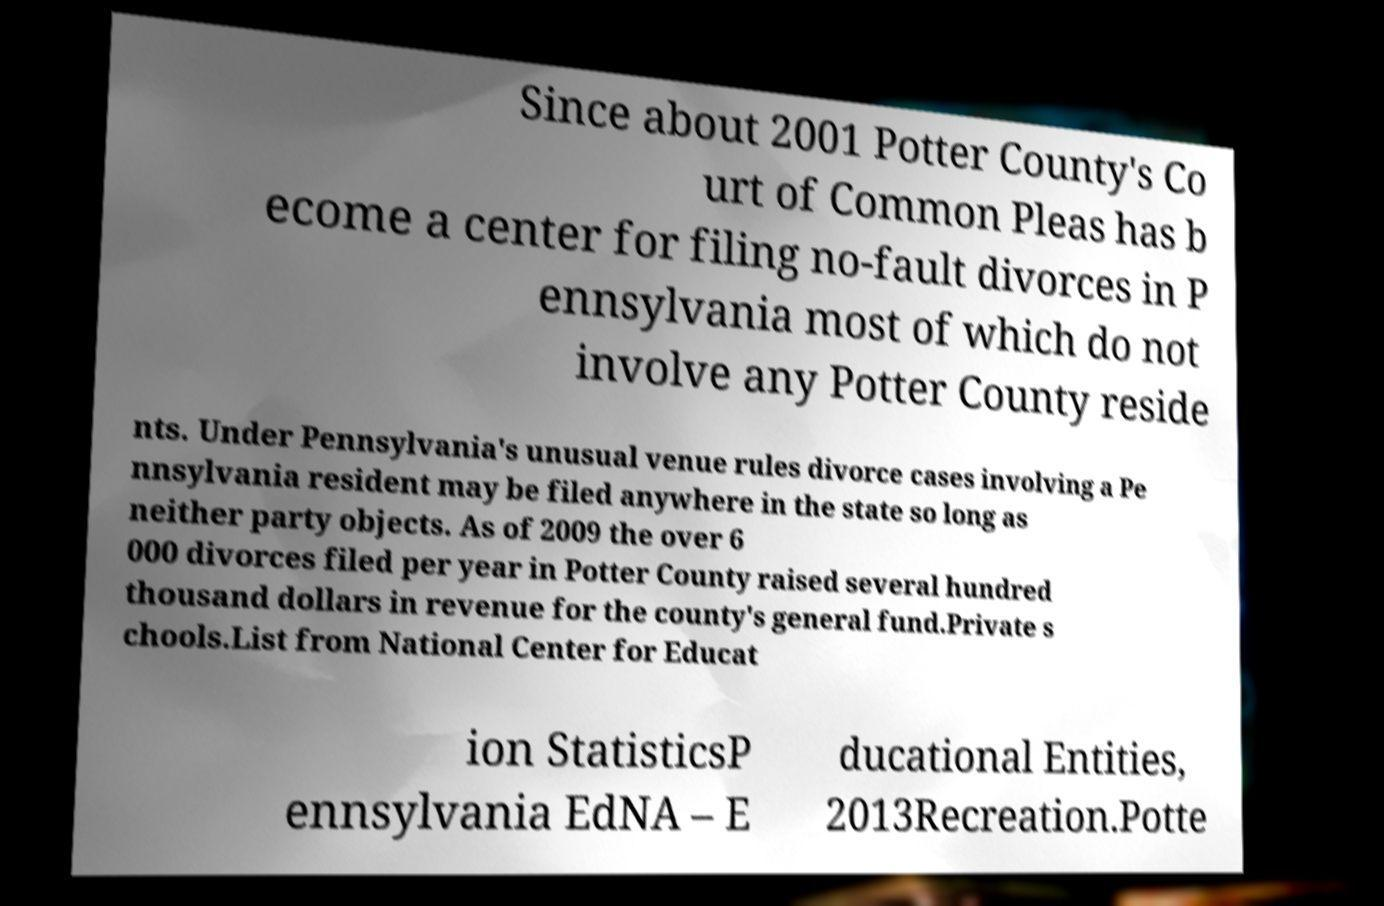Please identify and transcribe the text found in this image. Since about 2001 Potter County's Co urt of Common Pleas has b ecome a center for filing no-fault divorces in P ennsylvania most of which do not involve any Potter County reside nts. Under Pennsylvania's unusual venue rules divorce cases involving a Pe nnsylvania resident may be filed anywhere in the state so long as neither party objects. As of 2009 the over 6 000 divorces filed per year in Potter County raised several hundred thousand dollars in revenue for the county's general fund.Private s chools.List from National Center for Educat ion StatisticsP ennsylvania EdNA – E ducational Entities, 2013Recreation.Potte 